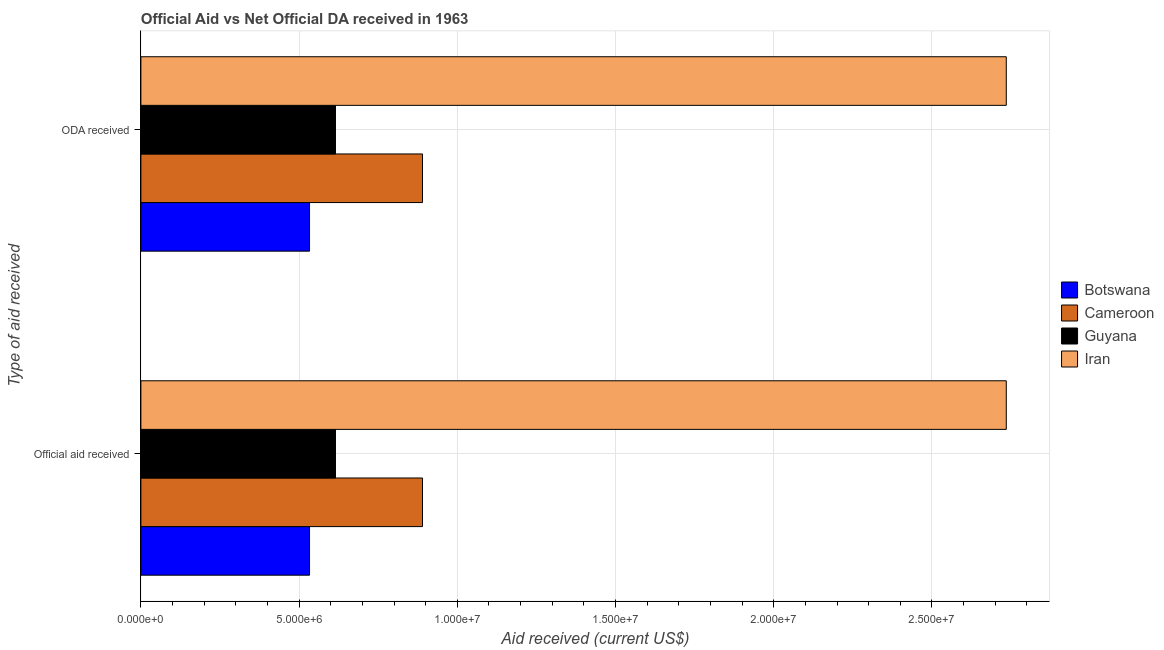How many different coloured bars are there?
Your answer should be compact. 4. How many groups of bars are there?
Ensure brevity in your answer.  2. Are the number of bars per tick equal to the number of legend labels?
Provide a short and direct response. Yes. What is the label of the 1st group of bars from the top?
Provide a succinct answer. ODA received. What is the oda received in Cameroon?
Keep it short and to the point. 8.90e+06. Across all countries, what is the maximum oda received?
Your answer should be compact. 2.74e+07. Across all countries, what is the minimum oda received?
Give a very brief answer. 5.33e+06. In which country was the official aid received maximum?
Keep it short and to the point. Iran. In which country was the oda received minimum?
Offer a terse response. Botswana. What is the total official aid received in the graph?
Offer a terse response. 4.77e+07. What is the difference between the oda received in Cameroon and that in Guyana?
Your response must be concise. 2.75e+06. What is the difference between the official aid received in Iran and the oda received in Cameroon?
Provide a succinct answer. 1.84e+07. What is the average official aid received per country?
Ensure brevity in your answer.  1.19e+07. In how many countries, is the oda received greater than 26000000 US$?
Offer a very short reply. 1. What is the ratio of the official aid received in Iran to that in Botswana?
Your answer should be compact. 5.13. Is the official aid received in Cameroon less than that in Guyana?
Give a very brief answer. No. What does the 3rd bar from the top in ODA received represents?
Your answer should be compact. Cameroon. What does the 4th bar from the bottom in Official aid received represents?
Offer a terse response. Iran. How many bars are there?
Provide a succinct answer. 8. Are all the bars in the graph horizontal?
Ensure brevity in your answer.  Yes. Does the graph contain any zero values?
Ensure brevity in your answer.  No. Does the graph contain grids?
Keep it short and to the point. Yes. How are the legend labels stacked?
Your answer should be compact. Vertical. What is the title of the graph?
Offer a terse response. Official Aid vs Net Official DA received in 1963 . What is the label or title of the X-axis?
Keep it short and to the point. Aid received (current US$). What is the label or title of the Y-axis?
Ensure brevity in your answer.  Type of aid received. What is the Aid received (current US$) in Botswana in Official aid received?
Give a very brief answer. 5.33e+06. What is the Aid received (current US$) of Cameroon in Official aid received?
Provide a succinct answer. 8.90e+06. What is the Aid received (current US$) in Guyana in Official aid received?
Make the answer very short. 6.15e+06. What is the Aid received (current US$) of Iran in Official aid received?
Provide a succinct answer. 2.74e+07. What is the Aid received (current US$) in Botswana in ODA received?
Make the answer very short. 5.33e+06. What is the Aid received (current US$) of Cameroon in ODA received?
Provide a succinct answer. 8.90e+06. What is the Aid received (current US$) in Guyana in ODA received?
Give a very brief answer. 6.15e+06. What is the Aid received (current US$) of Iran in ODA received?
Provide a short and direct response. 2.74e+07. Across all Type of aid received, what is the maximum Aid received (current US$) in Botswana?
Keep it short and to the point. 5.33e+06. Across all Type of aid received, what is the maximum Aid received (current US$) of Cameroon?
Ensure brevity in your answer.  8.90e+06. Across all Type of aid received, what is the maximum Aid received (current US$) in Guyana?
Keep it short and to the point. 6.15e+06. Across all Type of aid received, what is the maximum Aid received (current US$) of Iran?
Provide a succinct answer. 2.74e+07. Across all Type of aid received, what is the minimum Aid received (current US$) of Botswana?
Provide a succinct answer. 5.33e+06. Across all Type of aid received, what is the minimum Aid received (current US$) in Cameroon?
Provide a succinct answer. 8.90e+06. Across all Type of aid received, what is the minimum Aid received (current US$) in Guyana?
Your response must be concise. 6.15e+06. Across all Type of aid received, what is the minimum Aid received (current US$) of Iran?
Provide a succinct answer. 2.74e+07. What is the total Aid received (current US$) in Botswana in the graph?
Your answer should be compact. 1.07e+07. What is the total Aid received (current US$) in Cameroon in the graph?
Your response must be concise. 1.78e+07. What is the total Aid received (current US$) of Guyana in the graph?
Offer a very short reply. 1.23e+07. What is the total Aid received (current US$) of Iran in the graph?
Offer a very short reply. 5.47e+07. What is the difference between the Aid received (current US$) of Botswana in Official aid received and that in ODA received?
Keep it short and to the point. 0. What is the difference between the Aid received (current US$) in Guyana in Official aid received and that in ODA received?
Offer a terse response. 0. What is the difference between the Aid received (current US$) of Iran in Official aid received and that in ODA received?
Provide a short and direct response. 0. What is the difference between the Aid received (current US$) of Botswana in Official aid received and the Aid received (current US$) of Cameroon in ODA received?
Ensure brevity in your answer.  -3.57e+06. What is the difference between the Aid received (current US$) in Botswana in Official aid received and the Aid received (current US$) in Guyana in ODA received?
Offer a very short reply. -8.20e+05. What is the difference between the Aid received (current US$) of Botswana in Official aid received and the Aid received (current US$) of Iran in ODA received?
Keep it short and to the point. -2.20e+07. What is the difference between the Aid received (current US$) in Cameroon in Official aid received and the Aid received (current US$) in Guyana in ODA received?
Your answer should be compact. 2.75e+06. What is the difference between the Aid received (current US$) in Cameroon in Official aid received and the Aid received (current US$) in Iran in ODA received?
Offer a very short reply. -1.84e+07. What is the difference between the Aid received (current US$) of Guyana in Official aid received and the Aid received (current US$) of Iran in ODA received?
Offer a very short reply. -2.12e+07. What is the average Aid received (current US$) in Botswana per Type of aid received?
Give a very brief answer. 5.33e+06. What is the average Aid received (current US$) of Cameroon per Type of aid received?
Provide a short and direct response. 8.90e+06. What is the average Aid received (current US$) in Guyana per Type of aid received?
Offer a terse response. 6.15e+06. What is the average Aid received (current US$) in Iran per Type of aid received?
Provide a succinct answer. 2.74e+07. What is the difference between the Aid received (current US$) of Botswana and Aid received (current US$) of Cameroon in Official aid received?
Offer a very short reply. -3.57e+06. What is the difference between the Aid received (current US$) in Botswana and Aid received (current US$) in Guyana in Official aid received?
Provide a short and direct response. -8.20e+05. What is the difference between the Aid received (current US$) of Botswana and Aid received (current US$) of Iran in Official aid received?
Offer a very short reply. -2.20e+07. What is the difference between the Aid received (current US$) of Cameroon and Aid received (current US$) of Guyana in Official aid received?
Your response must be concise. 2.75e+06. What is the difference between the Aid received (current US$) of Cameroon and Aid received (current US$) of Iran in Official aid received?
Ensure brevity in your answer.  -1.84e+07. What is the difference between the Aid received (current US$) in Guyana and Aid received (current US$) in Iran in Official aid received?
Your answer should be compact. -2.12e+07. What is the difference between the Aid received (current US$) of Botswana and Aid received (current US$) of Cameroon in ODA received?
Keep it short and to the point. -3.57e+06. What is the difference between the Aid received (current US$) of Botswana and Aid received (current US$) of Guyana in ODA received?
Your answer should be very brief. -8.20e+05. What is the difference between the Aid received (current US$) in Botswana and Aid received (current US$) in Iran in ODA received?
Your answer should be compact. -2.20e+07. What is the difference between the Aid received (current US$) in Cameroon and Aid received (current US$) in Guyana in ODA received?
Your answer should be compact. 2.75e+06. What is the difference between the Aid received (current US$) of Cameroon and Aid received (current US$) of Iran in ODA received?
Your response must be concise. -1.84e+07. What is the difference between the Aid received (current US$) in Guyana and Aid received (current US$) in Iran in ODA received?
Ensure brevity in your answer.  -2.12e+07. What is the ratio of the Aid received (current US$) in Botswana in Official aid received to that in ODA received?
Provide a succinct answer. 1. What is the ratio of the Aid received (current US$) in Guyana in Official aid received to that in ODA received?
Provide a succinct answer. 1. What is the ratio of the Aid received (current US$) in Iran in Official aid received to that in ODA received?
Make the answer very short. 1. What is the difference between the highest and the second highest Aid received (current US$) in Iran?
Your answer should be very brief. 0. What is the difference between the highest and the lowest Aid received (current US$) of Botswana?
Ensure brevity in your answer.  0. What is the difference between the highest and the lowest Aid received (current US$) of Guyana?
Provide a short and direct response. 0. What is the difference between the highest and the lowest Aid received (current US$) of Iran?
Ensure brevity in your answer.  0. 